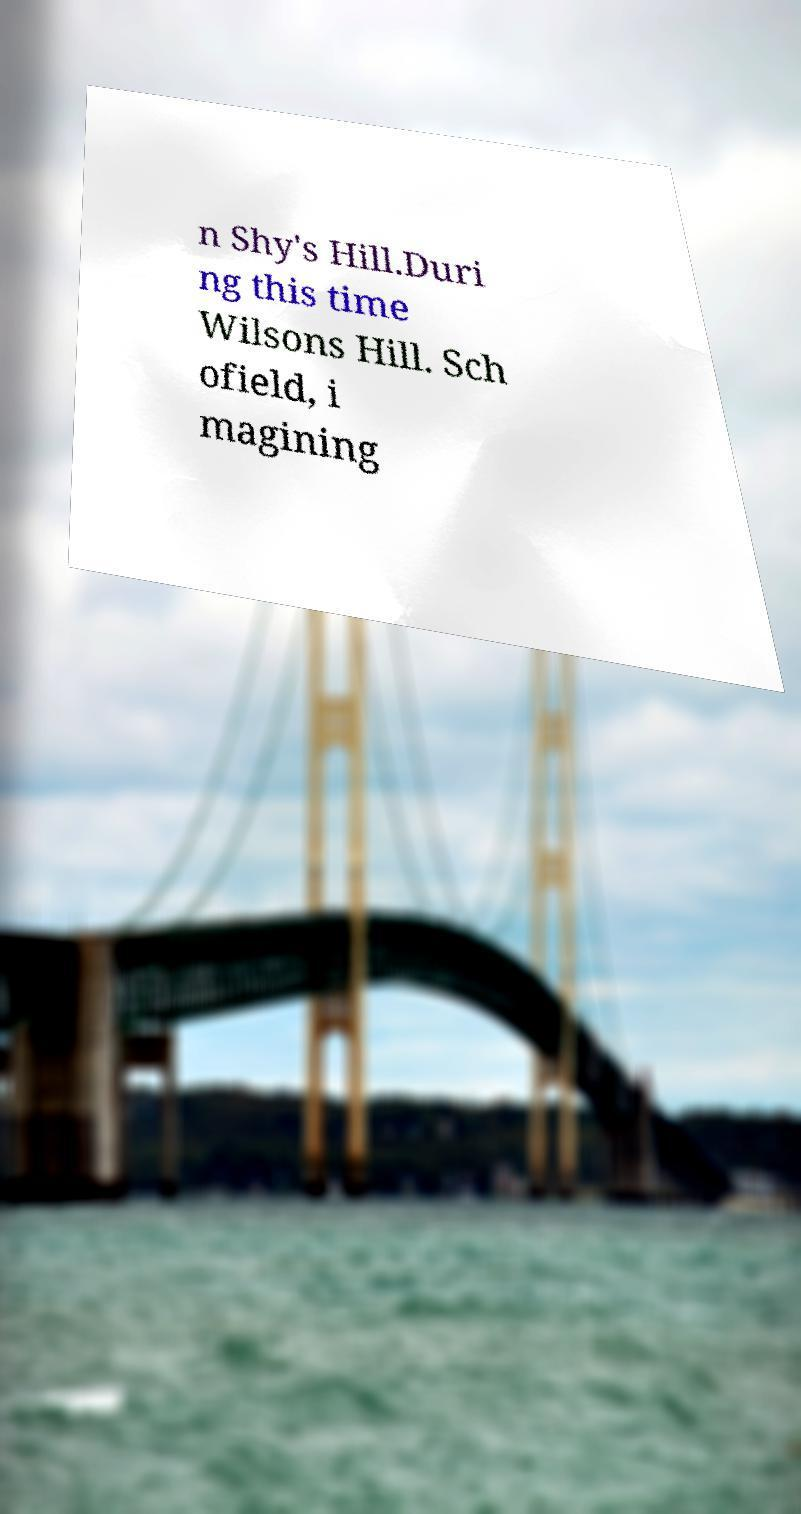There's text embedded in this image that I need extracted. Can you transcribe it verbatim? n Shy's Hill.Duri ng this time Wilsons Hill. Sch ofield, i magining 